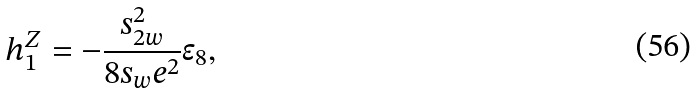Convert formula to latex. <formula><loc_0><loc_0><loc_500><loc_500>h _ { 1 } ^ { Z } = - \frac { s _ { 2 w } ^ { 2 } } { 8 s _ { w } e ^ { 2 } } \epsilon _ { 8 } ,</formula> 